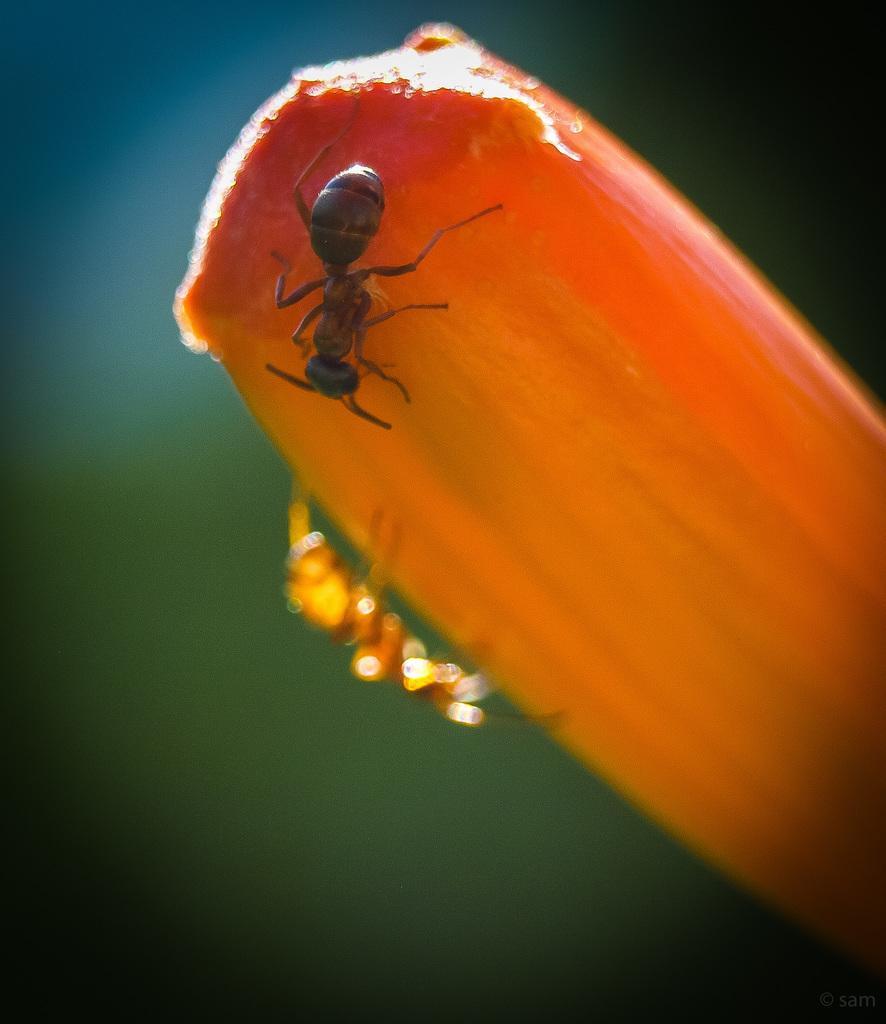Describe this image in one or two sentences. This picture contains an ice cream, which is orange in color. On the ice cream, there are two ants. In the background, it is green in color and it is blurred in the background. 